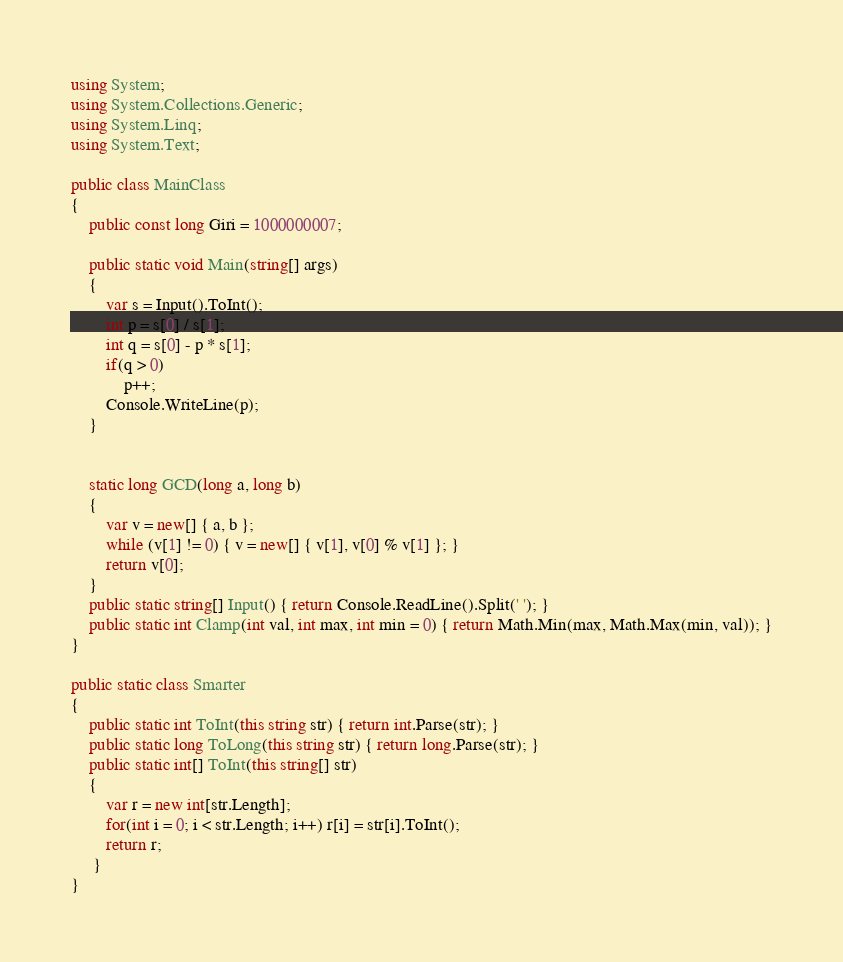Convert code to text. <code><loc_0><loc_0><loc_500><loc_500><_C#_>using System;
using System.Collections.Generic;
using System.Linq;
using System.Text;

public class MainClass
{
	public const long Giri = 1000000007;
	
	public static void Main(string[] args)
	{
		var s = Input().ToInt();
		int p = s[0] / s[1];
		int q = s[0] - p * s[1];
		if(q > 0)
			p++;
		Console.WriteLine(p);
	}


	static long GCD(long a, long b)
	{
		var v = new[] { a, b };
		while (v[1] != 0) { v = new[] { v[1], v[0] % v[1] }; }
		return v[0];
	}
	public static string[] Input() { return Console.ReadLine().Split(' '); }
	public static int Clamp(int val, int max, int min = 0) { return Math.Min(max, Math.Max(min, val)); }
}

public static class Smarter
{
	public static int ToInt(this string str) { return int.Parse(str); }
	public static long ToLong(this string str) { return long.Parse(str); }
	public static int[] ToInt(this string[] str)
	{
		var r = new int[str.Length];
		for(int i = 0; i < str.Length; i++) r[i] = str[i].ToInt();
		return r;
	 }
}
</code> 